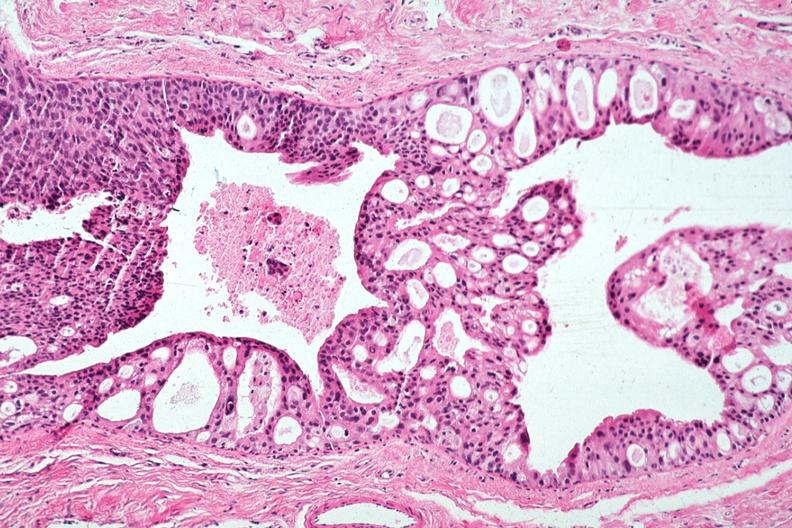does this image show excellent cribriform pattern all tumor in duct?
Answer the question using a single word or phrase. Yes 